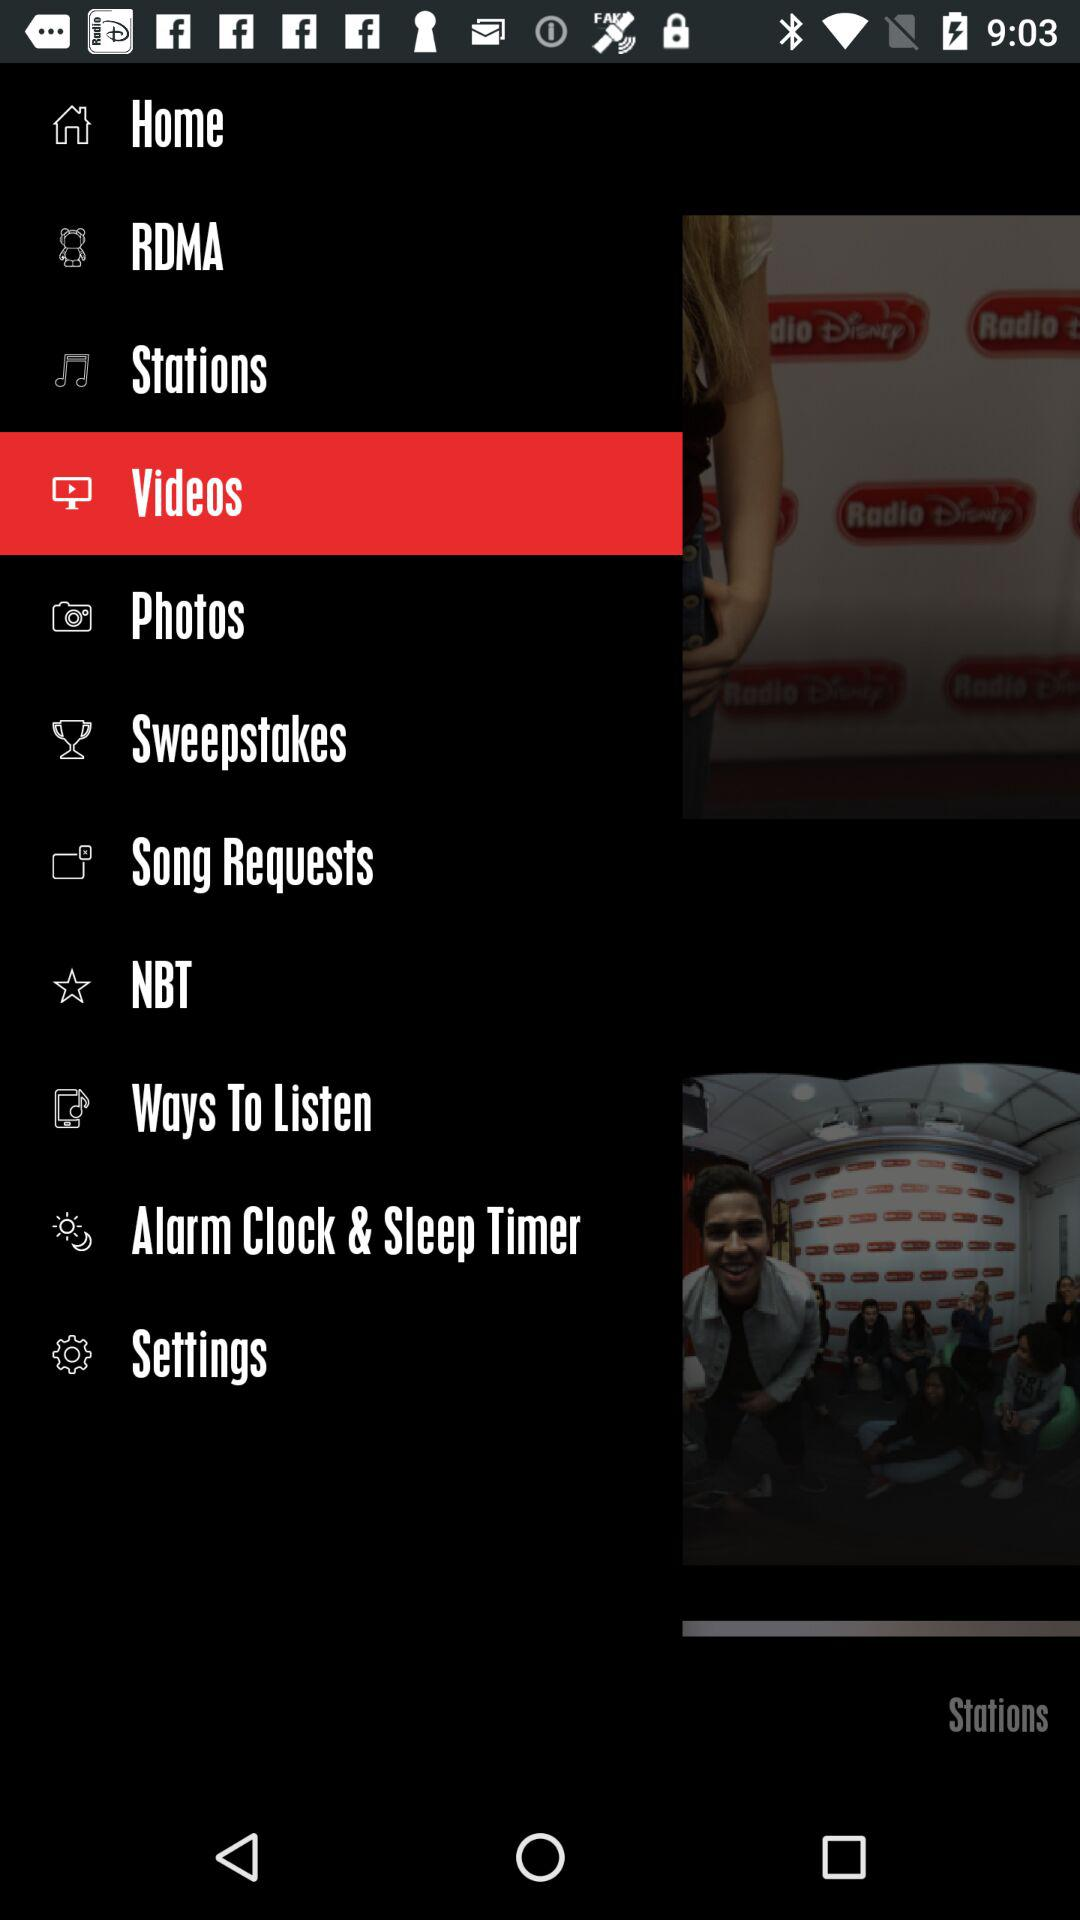What is the selected item? The selected item is "Videos". 